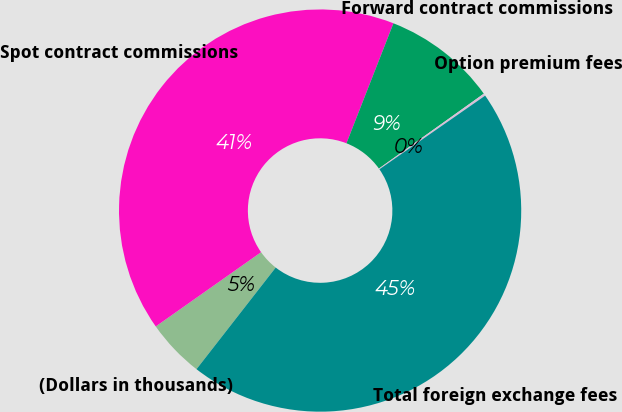Convert chart to OTSL. <chart><loc_0><loc_0><loc_500><loc_500><pie_chart><fcel>(Dollars in thousands)<fcel>Spot contract commissions<fcel>Forward contract commissions<fcel>Option premium fees<fcel>Total foreign exchange fees<nl><fcel>4.69%<fcel>40.72%<fcel>9.19%<fcel>0.19%<fcel>45.22%<nl></chart> 